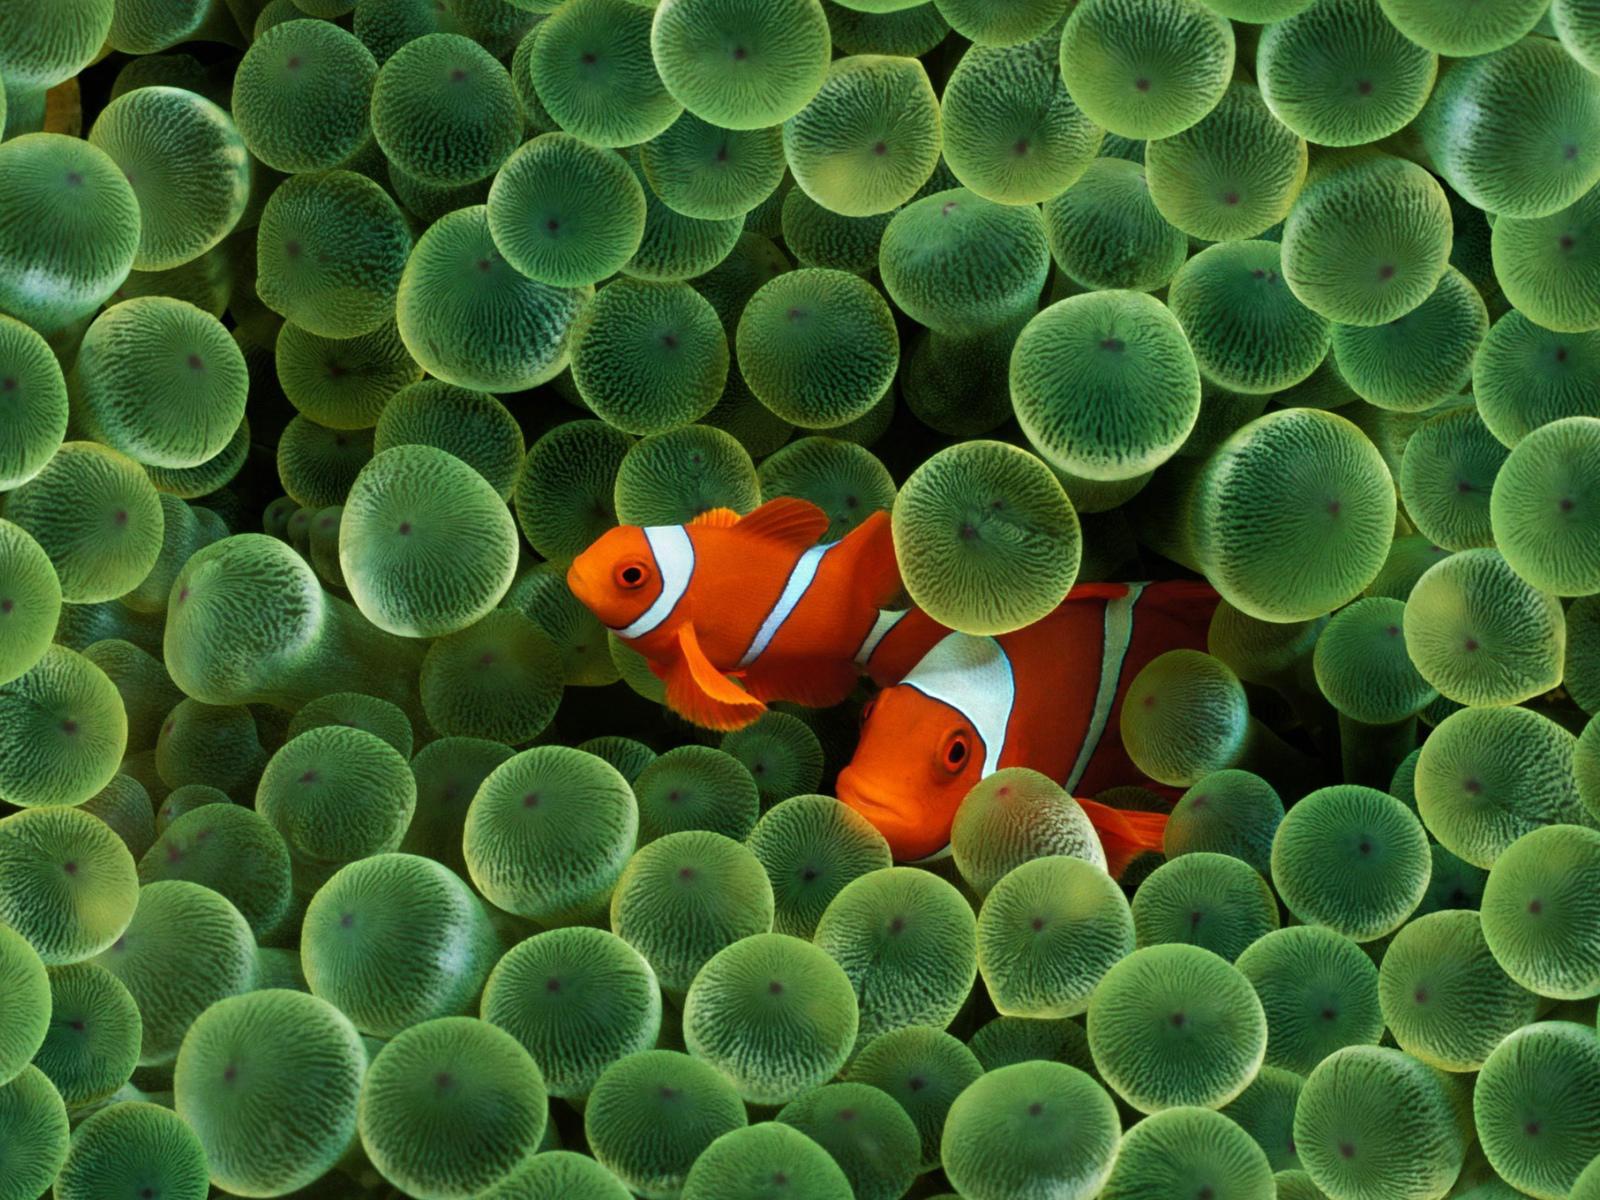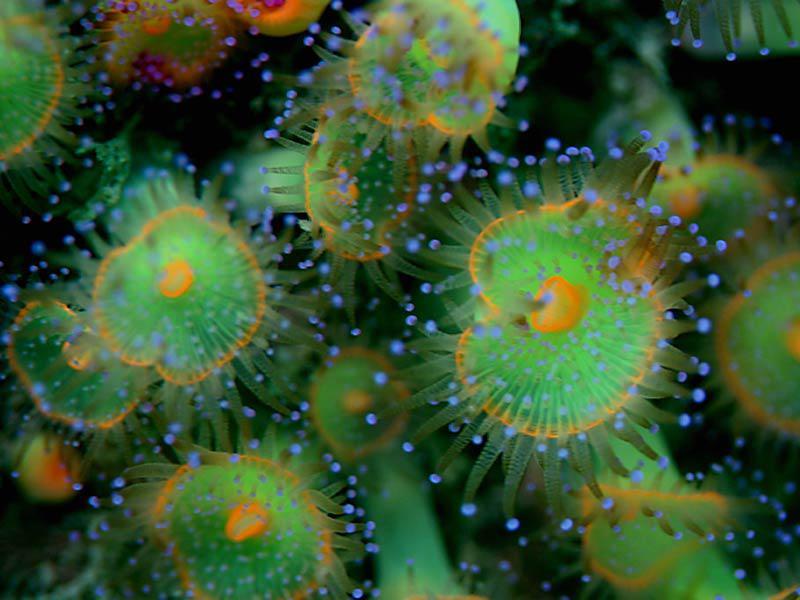The first image is the image on the left, the second image is the image on the right. Assess this claim about the two images: "Each image features lime-green anemone with tapered tendrils, and at least one image contains a single lime-green anemone.". Correct or not? Answer yes or no. No. The first image is the image on the left, the second image is the image on the right. Given the left and right images, does the statement "There are more sea organisms in the image on the left." hold true? Answer yes or no. Yes. 